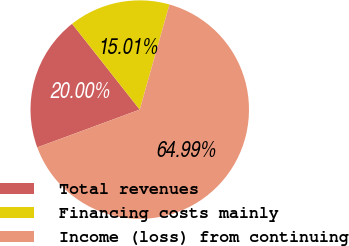Convert chart to OTSL. <chart><loc_0><loc_0><loc_500><loc_500><pie_chart><fcel>Total revenues<fcel>Financing costs mainly<fcel>Income (loss) from continuing<nl><fcel>20.0%<fcel>15.01%<fcel>64.99%<nl></chart> 